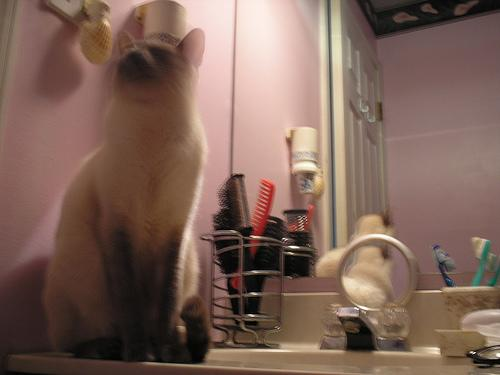Concisely define the focal point of the image and the activity it is involved in. The image's focal point is a Siamese cat positioned on a bathroom sink, appearing to gaze upwards at someone. What is the central element in the image and what is it engaged in? The central element is a Siamese cat, which is resting on the bathroom sink and staring up at someone. Identify the most eye-catching object in the image and explain its activity. The most attention-grabbing object, a Siamese cat, is perched on the bathroom sink and appears to be looking up at its owner. Depict the chief subject in the image and its current action. A Siamese cat, the chief subject, is sitting on the bathroom sink and directing its gaze upwards at its owner. Briefly describe the main object in the image and what it seems to be doing. The main object, a Siamese cat, is perched on a bathroom sink, apparently looking up toward its owner. Illustrate the primary object and its activity in the image. The primary object in the image, a Siamese cat, sits comfortably on a bathroom sink while looking up attentively at someone. Write a brief sentence highlighting the key focus of the image and what it is engaged in. The image's key focus is a Siamese cat sitting on the sink and looking up at someone out of the frame. Tell us about the main subject of the image and its action. The main subject is a Siamese cat that is sitting on the bathroom sink and gazing up towards its owner. Provide a brief description of the primary object in the image and its action. A Siamese cat is sitting on a bathroom sink, looking up at its owner. Mention the most prominent feature in the image and describe what it is doing. The dominant feature, a Siamese cat, sits on a bathroom sink and gazes upward at its owner. Could you find the orange hairbrush in the metal container? There is no mention of an orange hairbrush in the image; instead, there's a bright red wide tooth comb. I see a blue toothpaste dispenser on the counter. There is no toothpaste dispenser mentioned in the image, only a white cup dispenser. The unique floor tiles are visible in the bathroom mirror's reflection. There is no mention of the floor or the floor tiles in the given information. Please hand me the small rectangular mirror next to the comb. The mirror mentioned in the image is actually round, not rectangular. Is the bathroom door a light shade of pink? The door is not mentioned to be pink; it is just described as a white bathroom door, as reflected in the mirror. Look for the yellow toothbrush in the holder. There is no yellow toothbrush mentioned in the image, but there are bright green, bright blue, and turquoise toothbrushes. Isn't it funny how the cat is sleeping soundly on the bathroom counter? The cat is neither sleeping nor described as sleeping; it is either sitting or looking up at the owner. Is there a cute black dog on the bathroom counter? The image actually features a white and brown Siamese cat and a grey and white cat on the counter, not a black dog. Notice the beautiful painting hanging on the bathroom wall. There is no painting mentioned in the image, only a seashell-shaped nightlight and wallpaper border. Does the large bathroom mirror have a gold frame? The large bathroom mirror is not described to have a gold frame; its attributes are not mentioned. 